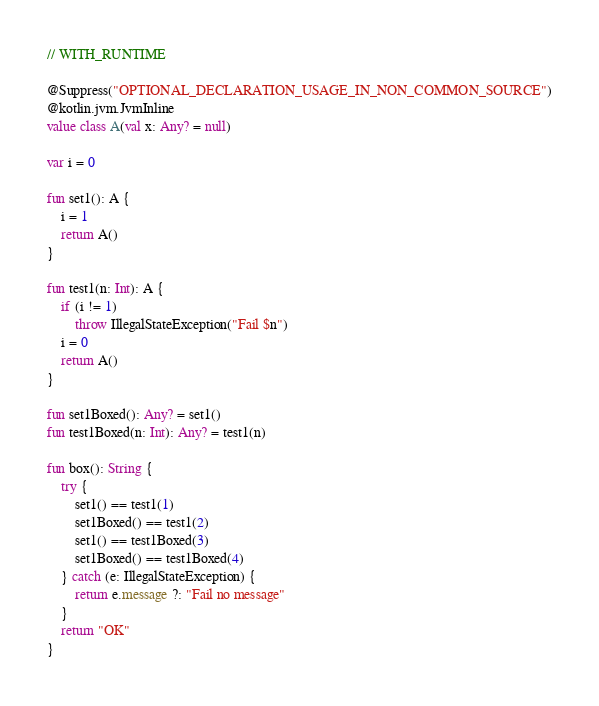Convert code to text. <code><loc_0><loc_0><loc_500><loc_500><_Kotlin_>
// WITH_RUNTIME

@Suppress("OPTIONAL_DECLARATION_USAGE_IN_NON_COMMON_SOURCE")
@kotlin.jvm.JvmInline
value class A(val x: Any? = null)

var i = 0

fun set1(): A {
    i = 1
    return A()
}

fun test1(n: Int): A {
    if (i != 1)
        throw IllegalStateException("Fail $n")
    i = 0
    return A()
}

fun set1Boxed(): Any? = set1()
fun test1Boxed(n: Int): Any? = test1(n)

fun box(): String {
    try {
        set1() == test1(1)
        set1Boxed() == test1(2)
        set1() == test1Boxed(3)
        set1Boxed() == test1Boxed(4)
    } catch (e: IllegalStateException) {
        return e.message ?: "Fail no message"
    }
    return "OK"
}
</code> 